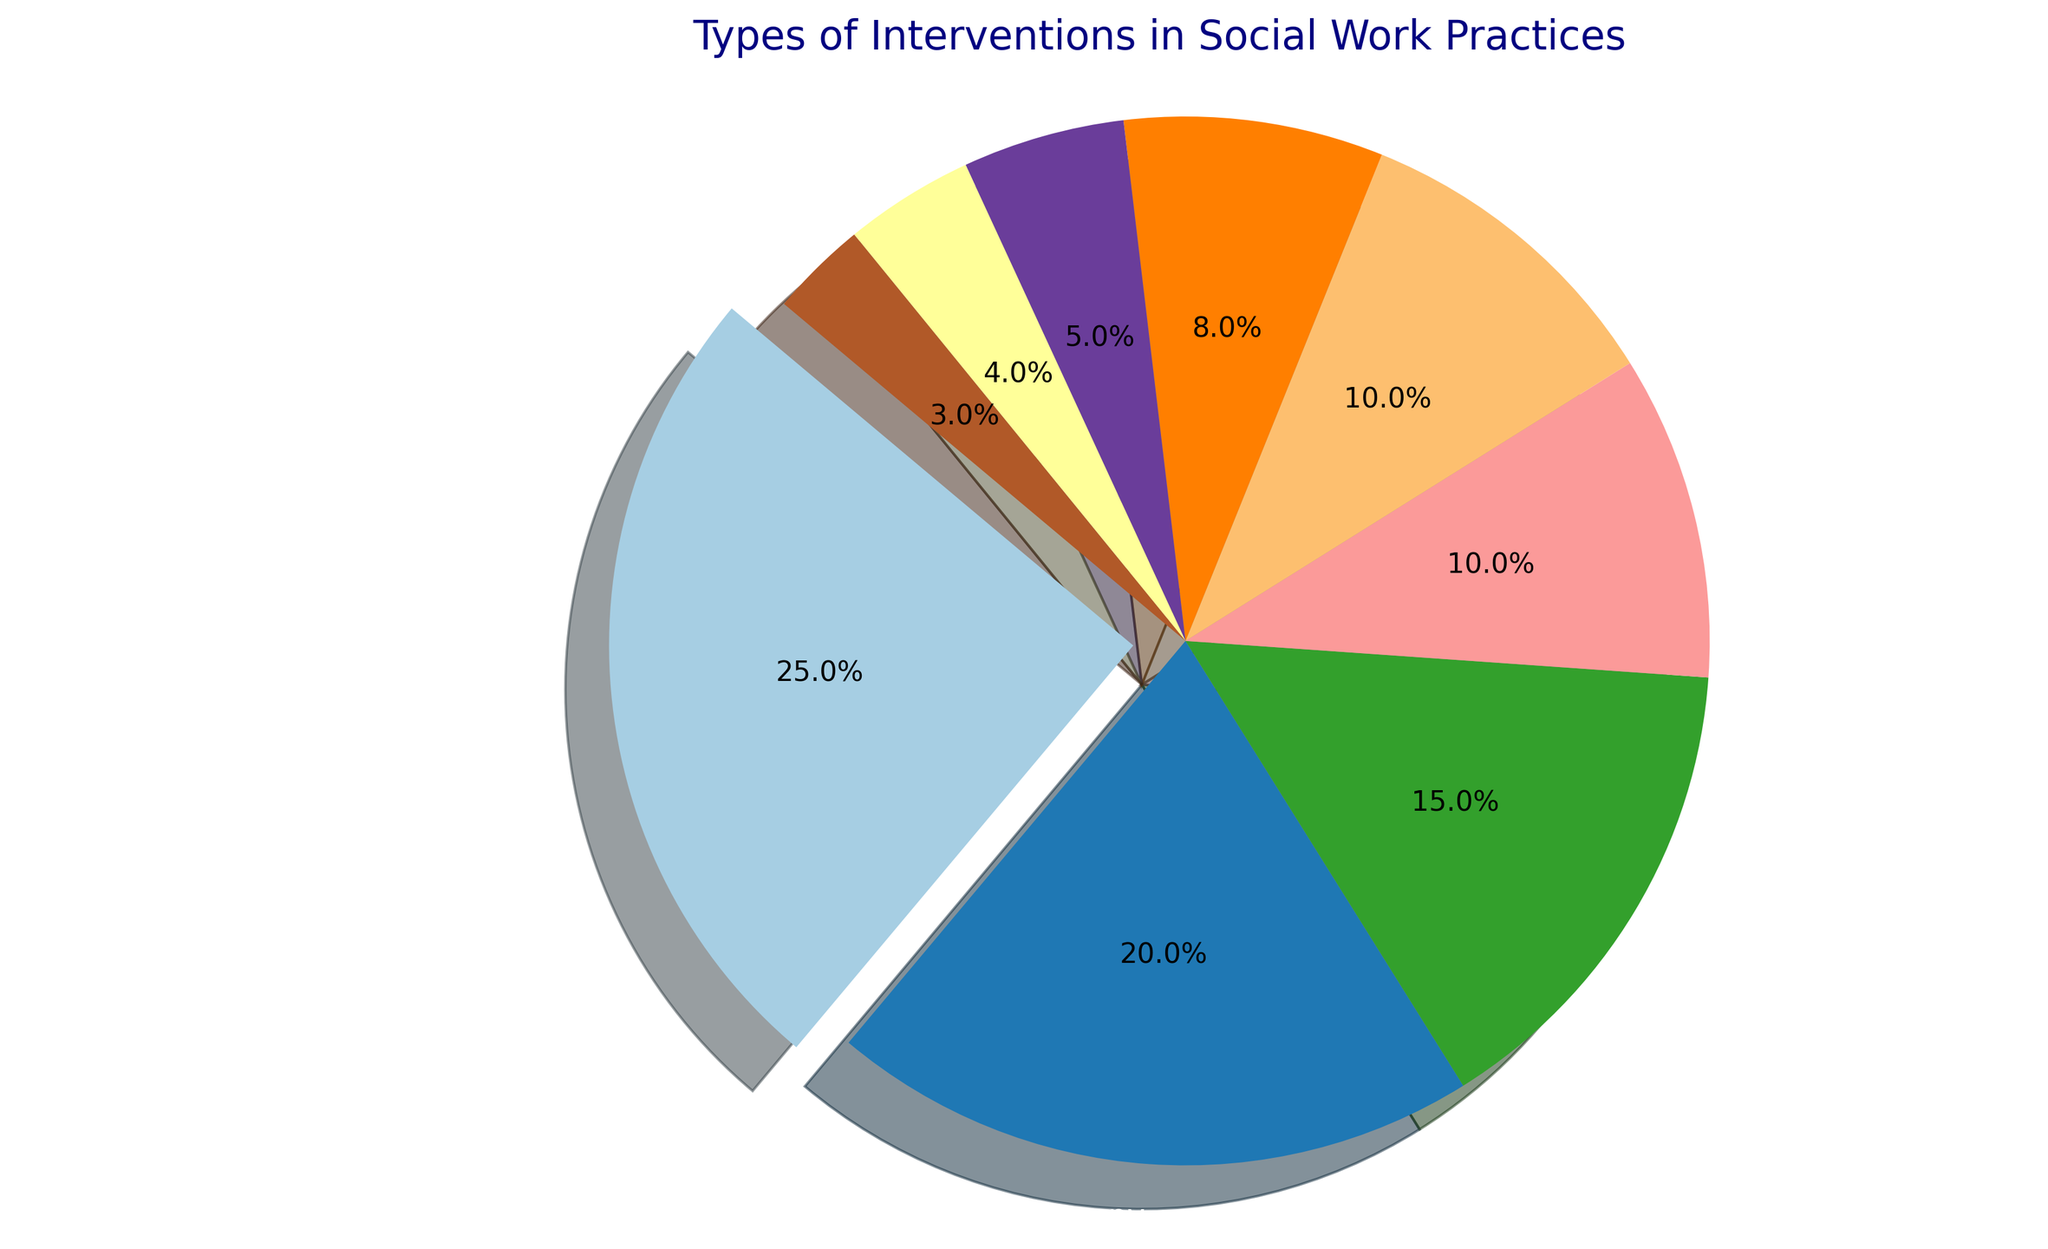What's the most commonly used intervention type? The wedge representing "Cognitive-Behavioral Therapy (CBT)" is the largest and is slightly 'exploded' out from the pie chart, indicating it has the highest percentage compared to other interventions.
Answer: Cognitive-Behavioral Therapy (CBT) Which intervention types make up less than 10% of the total interventions? The smaller wedges labeled "Case Management," "Solution-Focused Brief Therapy (SFBT)," "Motivational Interviewing (MI)," and "Dialectical Behavior Therapy (DBT)" are all less than 10% each, based on the percentages shown on the chart.
Answer: Case Management, Solution-Focused Brief Therapy (SFBT), Motivational Interviewing (MI), Dialectical Behavior Therapy (DBT) How much larger is the percentage of Cognitive-Behavioral Therapy (CBT) compared to Dialectical Behavior Therapy (DBT)? Cognitive-Behavioral Therapy (CBT) is 25% and Dialectical Behavior Therapy (DBT) is 3%. Subtracting the percentage of DBT from CBT gives us 25% - 3% = 22%.
Answer: 22% What is the combined percentage of Family Therapy and Crisis Intervention? Family Therapy has a percentage of 20% and Crisis Intervention has a percentage of 15%. Adding these two percentages together gives 20% + 15% = 35%.
Answer: 35% What color represents Vocational Training in the pie chart? The colors used in the chart follow the Paired color map of Matplotlib, and observing where "Vocational Training" is located, it is alongside other interventions. By visually identifying the segment, we can see the color used.
Answer: Light blue Which intervention type is smallest in the pie chart and what percentage does it represent? Observing the plot, the smallest wedge in the pie chart is labeled "Dialectical Behavior Therapy (DBT)" and it represents 3%.
Answer: Dialectical Behavior Therapy (DBT), 3% If we combine all intervention types above 10%, what would be their total percentage? Adding the percentages for "Cognitive-Behavioral Therapy (CBT)" (25%), "Family Therapy" (20%), "Crisis Intervention" (15%), and "Vocational Training" (10%) gives us a total percentage of 25% + 20% + 15% + 10% = 70%.
Answer: 70% How much more common is Group Therapy compared to Motivational Interviewing (MI)? Group Therapy is 10% and Motivational Interviewing (MI) is 4%. Subtract the percentage of MI from Group Therapy: 10% - 4% = 6%.
Answer: 6% What is the total percentage represented by the interventions that fall between 5% and 20%? The interventions within this range are "Family Therapy" (20%), "Crisis Intervention" (15%), "Vocational Training" (10%), "Group Therapy" (10%), and "Solution-Focused Brief Therapy (SFBT)" (5%). Adding these percentages together gives us 20% + 15% + 10% + 10% + 5% = 60%.
Answer: 60% How many intervention types are represented in the pie chart? Counting the labeled wedges in the pie chart, we see that there are nine different sections, each representing a different type of intervention.
Answer: 9 Which two intervention types have an equal percentage in the pie chart? Observing the pie chart, "Vocational Training" and "Group Therapy" both have wedges labeled as 10%.
Answer: Vocational Training, Group Therapy 